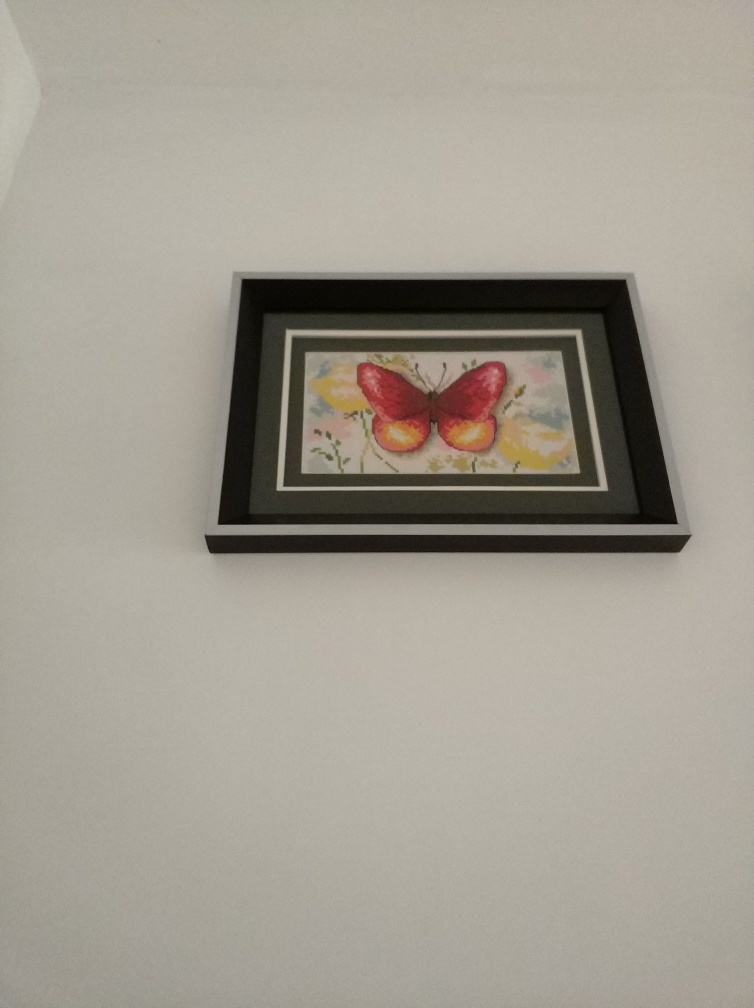How might the image influence the mood of a room? The gentle color scheme and serene subject matter of this artwork could contribute to a calming and peaceful ambiance in a room. Its soft pastel colors and the serene depiction of the butterfly would suit a space meant for relaxation or contemplation, such as a bedroom or a quiet study area. 